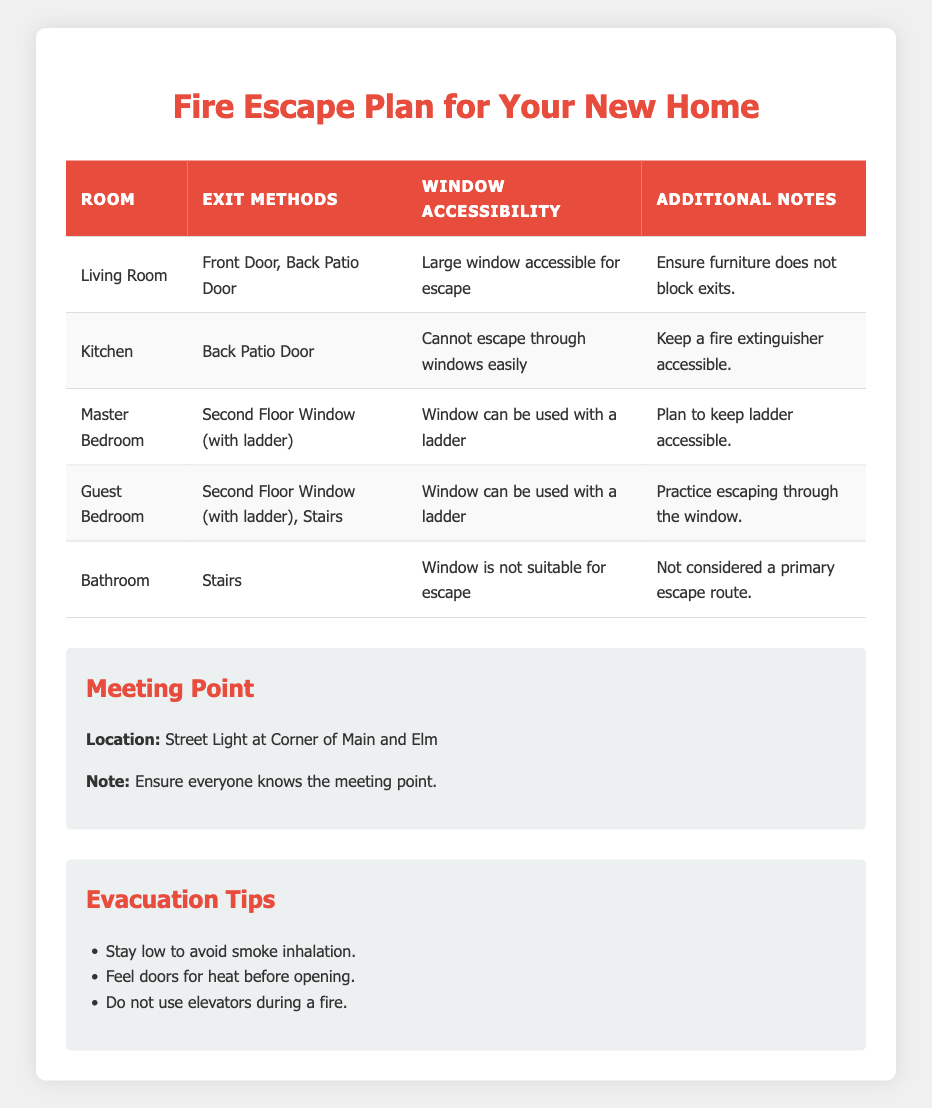What exit methods are available from the Kitchen? The table indicates that the exit method for the Kitchen is the Back Patio Door only.
Answer: Back Patio Door Which room has a large window accessible for escape? According to the table, the Living Room is the only room listed with a large window accessible for escape.
Answer: Living Room Can you escape through the Bathroom window? The table states that the window in the Bathroom is not suitable for escape, confirming that it cannot be used for exiting the home.
Answer: No How many rooms can exit through stairs? By reviewing the table, the Bathroom and Guest Bedroom are the only rooms that list stairs as an exit method. So, there are two rooms with this option.
Answer: 2 What is the primary meeting point for all family members? The meeting point is mentioned in the table as "Street Light at Corner of Main and Elm," which should be known to all family members.
Answer: Street Light at Corner of Main and Elm Do the Master Bedroom and Guest Bedroom have similar exit methods? Yes, both the Master Bedroom and Guest Bedroom have the option to use the window with a ladder as an exit method. Since the Guest Bedroom additionally has stairs, they are somewhat similar but not identical in all exit methods.
Answer: Yes, but Guest Bedroom has stairs too What should you do before opening doors during an evacuation? The evacuation tips recommend feeling doors for heat before opening them, as noted in the table.
Answer: Feel doors for heat Which room requires practicing escaping through the window? The Guest Bedroom requires practicing escaping through the window according to the additional notes provided in the table.
Answer: Guest Bedroom Is there a fire extinguisher noted as being accessible in the Kitchen? Yes, the Kitchen's additional notes specifically state to keep a fire extinguisher accessible for safety during a fire.
Answer: Yes If someone is in the Master Bedroom during a fire, what is the escape method? The escape method from the Master Bedroom is through the Second Floor Window using a ladder, as stated in the table.
Answer: Second Floor Window (with ladder) 